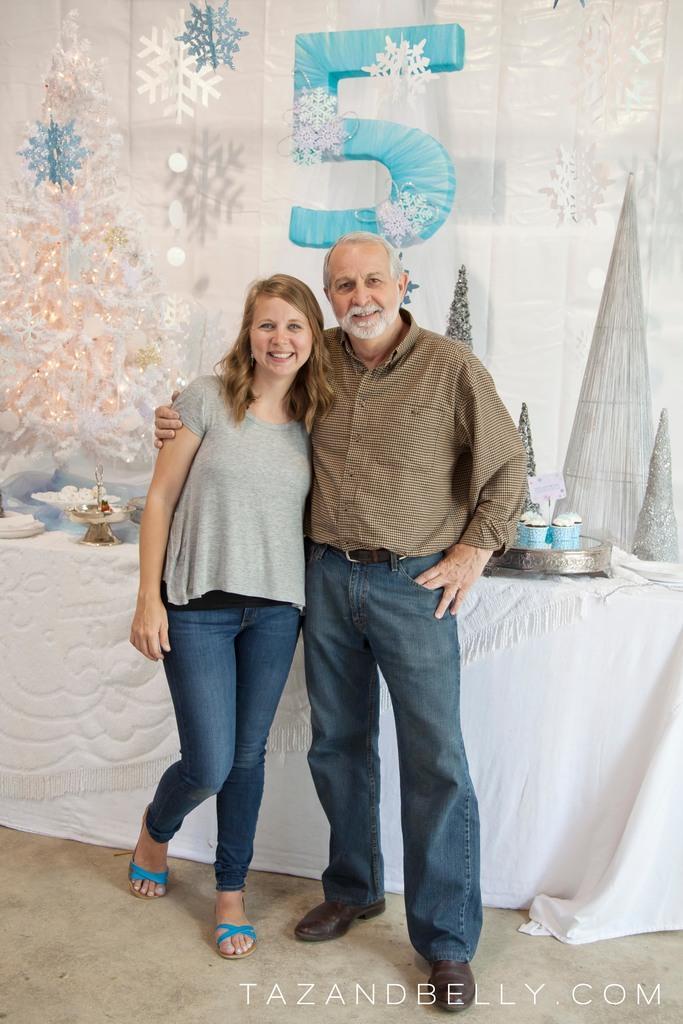In one or two sentences, can you explain what this image depicts? In this picture we can see a man and a woman standing and smiling. We can see some text in the bottom right. There are a few objects visible on the table. We can see a few decorative items in the background. 